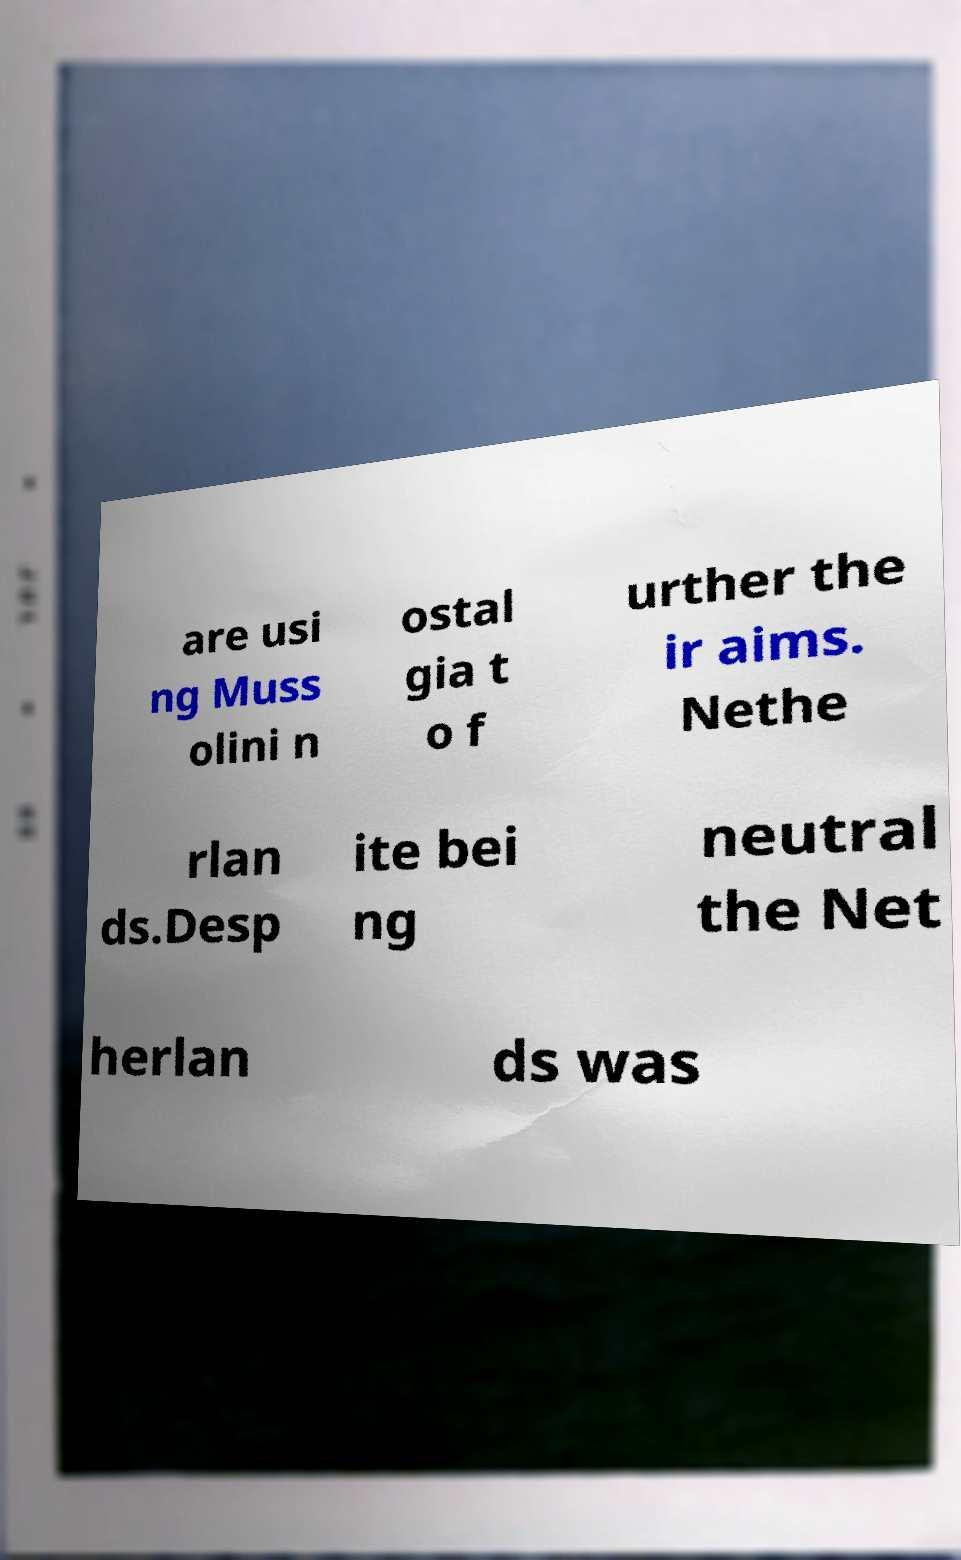Can you read and provide the text displayed in the image?This photo seems to have some interesting text. Can you extract and type it out for me? are usi ng Muss olini n ostal gia t o f urther the ir aims. Nethe rlan ds.Desp ite bei ng neutral the Net herlan ds was 